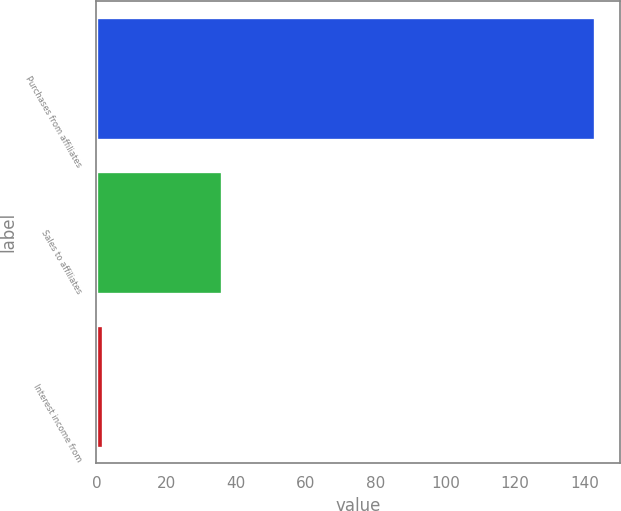<chart> <loc_0><loc_0><loc_500><loc_500><bar_chart><fcel>Purchases from affiliates<fcel>Sales to affiliates<fcel>Interest income from<nl><fcel>143<fcel>36<fcel>2<nl></chart> 